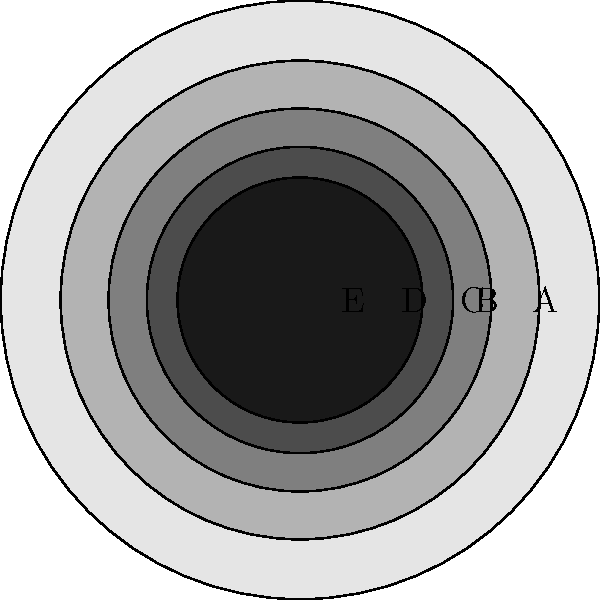In the graphic novel colorization process, which sequence of color gradients would best create the illusion of depth for a spherical object, moving from the outermost layer to the innermost? To create the illusion of depth for a spherical object using color gradients, we need to consider how light interacts with a three-dimensional sphere:

1. The outermost layer should be the lightest, as it would receive the most direct light.
2. Each subsequent inner layer should gradually become darker to simulate the curvature of the sphere and the decreasing amount of light reaching those areas.
3. The innermost layer should be the darkest, representing the area that receives the least amount of light.

Looking at the provided graphic:

A. The outermost ring is the lightest shade of gray.
B. The second ring is slightly darker.
C. The middle ring is a medium gray.
D. The fourth ring is a darker gray.
E. The innermost ring is the darkest shade of gray.

This gradual progression from light to dark creates the illusion of depth and dimensionality, making the flat circle appear more like a three-dimensional sphere.

Therefore, the correct sequence of color gradients to create the illusion of depth, moving from the outermost layer to the innermost, is A-B-C-D-E.
Answer: A-B-C-D-E 